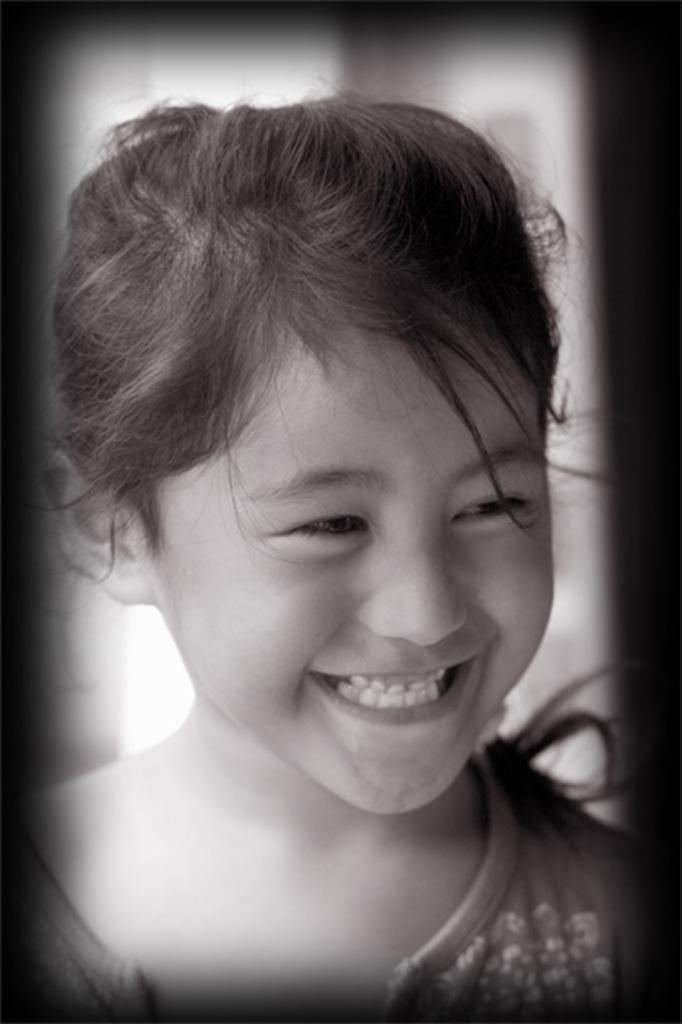Who is the main subject in the picture? There is a girl in the picture. What is the girl's expression in the image? The girl is smiling. Can you describe the background of the image? The background of the image is blurry. What type of rose can be seen in the girl's hair in the image? There is no rose present in the image; the girl's hair is not visible. 